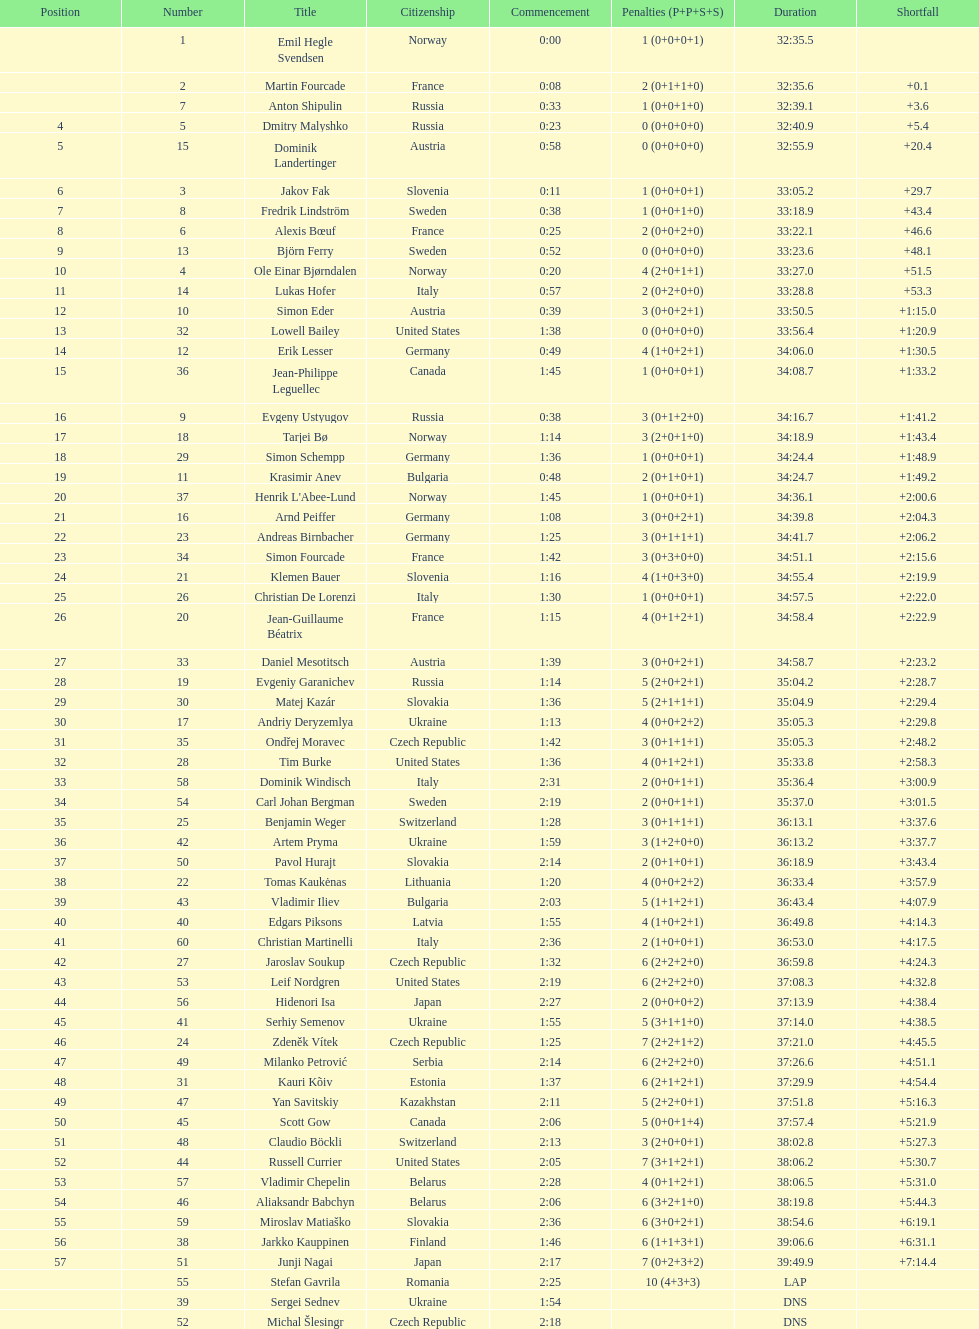What is the largest penalty? 10. 